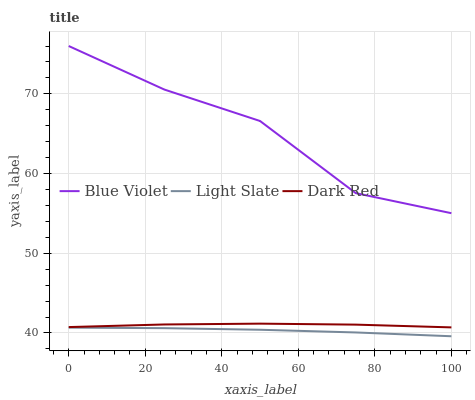Does Light Slate have the minimum area under the curve?
Answer yes or no. Yes. Does Blue Violet have the maximum area under the curve?
Answer yes or no. Yes. Does Dark Red have the minimum area under the curve?
Answer yes or no. No. Does Dark Red have the maximum area under the curve?
Answer yes or no. No. Is Light Slate the smoothest?
Answer yes or no. Yes. Is Blue Violet the roughest?
Answer yes or no. Yes. Is Dark Red the smoothest?
Answer yes or no. No. Is Dark Red the roughest?
Answer yes or no. No. Does Light Slate have the lowest value?
Answer yes or no. Yes. Does Dark Red have the lowest value?
Answer yes or no. No. Does Blue Violet have the highest value?
Answer yes or no. Yes. Does Dark Red have the highest value?
Answer yes or no. No. Is Dark Red less than Blue Violet?
Answer yes or no. Yes. Is Blue Violet greater than Light Slate?
Answer yes or no. Yes. Does Dark Red intersect Blue Violet?
Answer yes or no. No. 